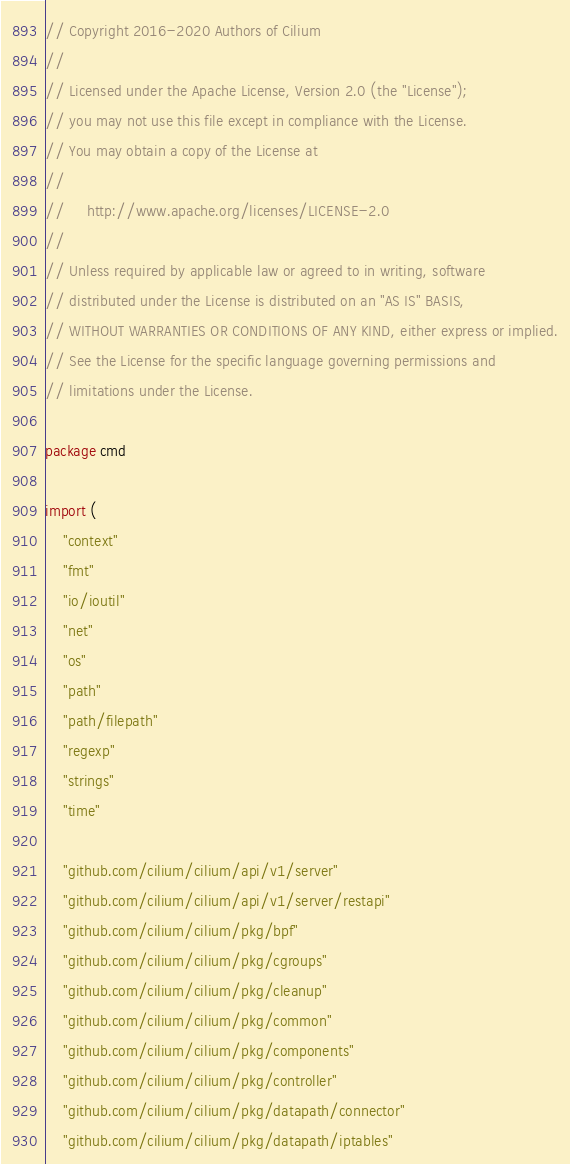<code> <loc_0><loc_0><loc_500><loc_500><_Go_>// Copyright 2016-2020 Authors of Cilium
//
// Licensed under the Apache License, Version 2.0 (the "License");
// you may not use this file except in compliance with the License.
// You may obtain a copy of the License at
//
//     http://www.apache.org/licenses/LICENSE-2.0
//
// Unless required by applicable law or agreed to in writing, software
// distributed under the License is distributed on an "AS IS" BASIS,
// WITHOUT WARRANTIES OR CONDITIONS OF ANY KIND, either express or implied.
// See the License for the specific language governing permissions and
// limitations under the License.

package cmd

import (
	"context"
	"fmt"
	"io/ioutil"
	"net"
	"os"
	"path"
	"path/filepath"
	"regexp"
	"strings"
	"time"

	"github.com/cilium/cilium/api/v1/server"
	"github.com/cilium/cilium/api/v1/server/restapi"
	"github.com/cilium/cilium/pkg/bpf"
	"github.com/cilium/cilium/pkg/cgroups"
	"github.com/cilium/cilium/pkg/cleanup"
	"github.com/cilium/cilium/pkg/common"
	"github.com/cilium/cilium/pkg/components"
	"github.com/cilium/cilium/pkg/controller"
	"github.com/cilium/cilium/pkg/datapath/connector"
	"github.com/cilium/cilium/pkg/datapath/iptables"</code> 